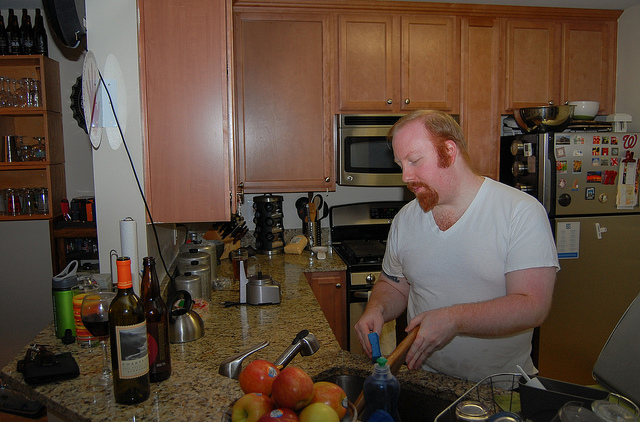What meal seems to be in preparation? Based on the items on the counter, including a variety of fruits and what appears to be a soda bottle, it might be the prep for a fruit salad or perhaps a refreshing beverage to accompany a meal. 